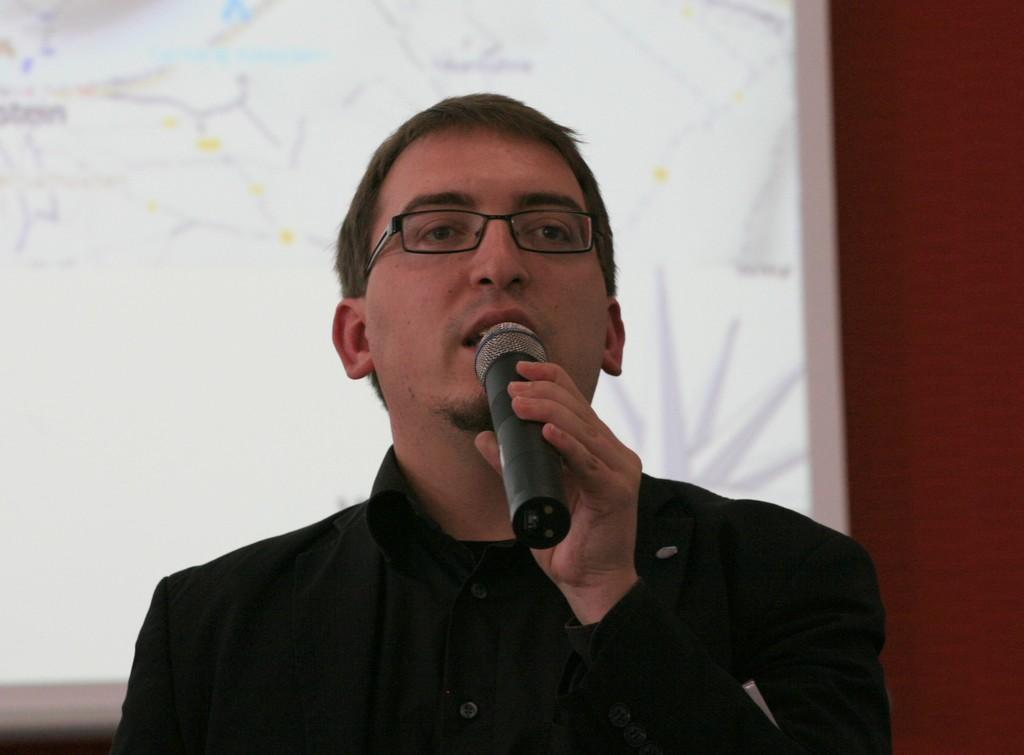What is the person in the image doing? The person is standing and holding a microphone. What might the person be doing with the microphone? The person's mouth is open, suggesting they are talking into the microphone. What can be seen in the background of the image? There is a white color board in the background of the image. What type of honey can be seen dripping from the microphone in the image? There is no honey present in the image; the person is holding a microphone and talking. 